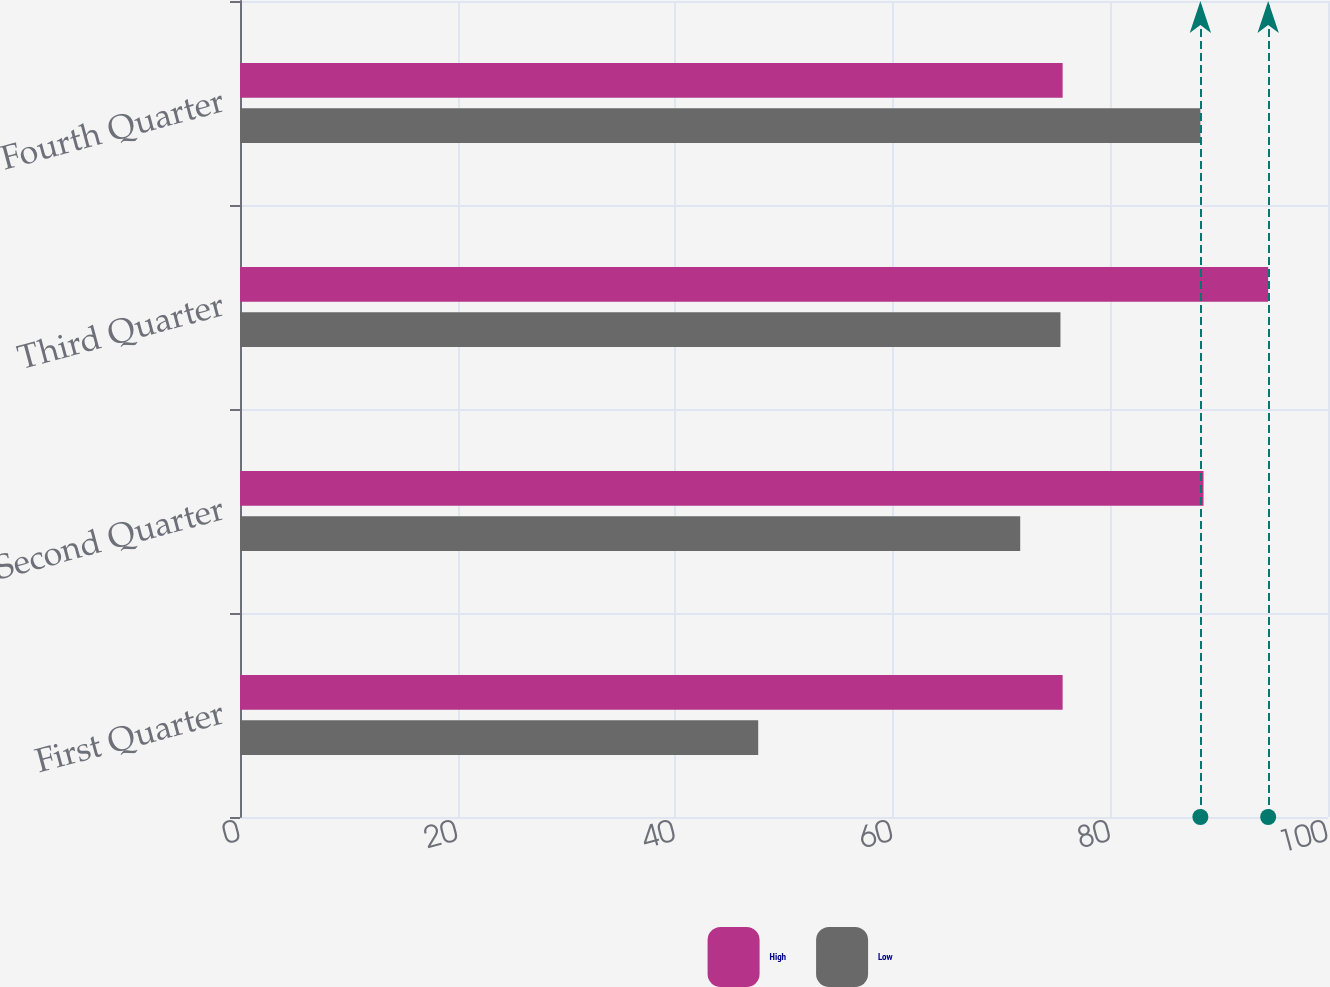<chart> <loc_0><loc_0><loc_500><loc_500><stacked_bar_chart><ecel><fcel>First Quarter<fcel>Second Quarter<fcel>Third Quarter<fcel>Fourth Quarter<nl><fcel>High<fcel>75.61<fcel>88.56<fcel>94.5<fcel>75.61<nl><fcel>Low<fcel>47.63<fcel>71.71<fcel>75.41<fcel>88.27<nl></chart> 